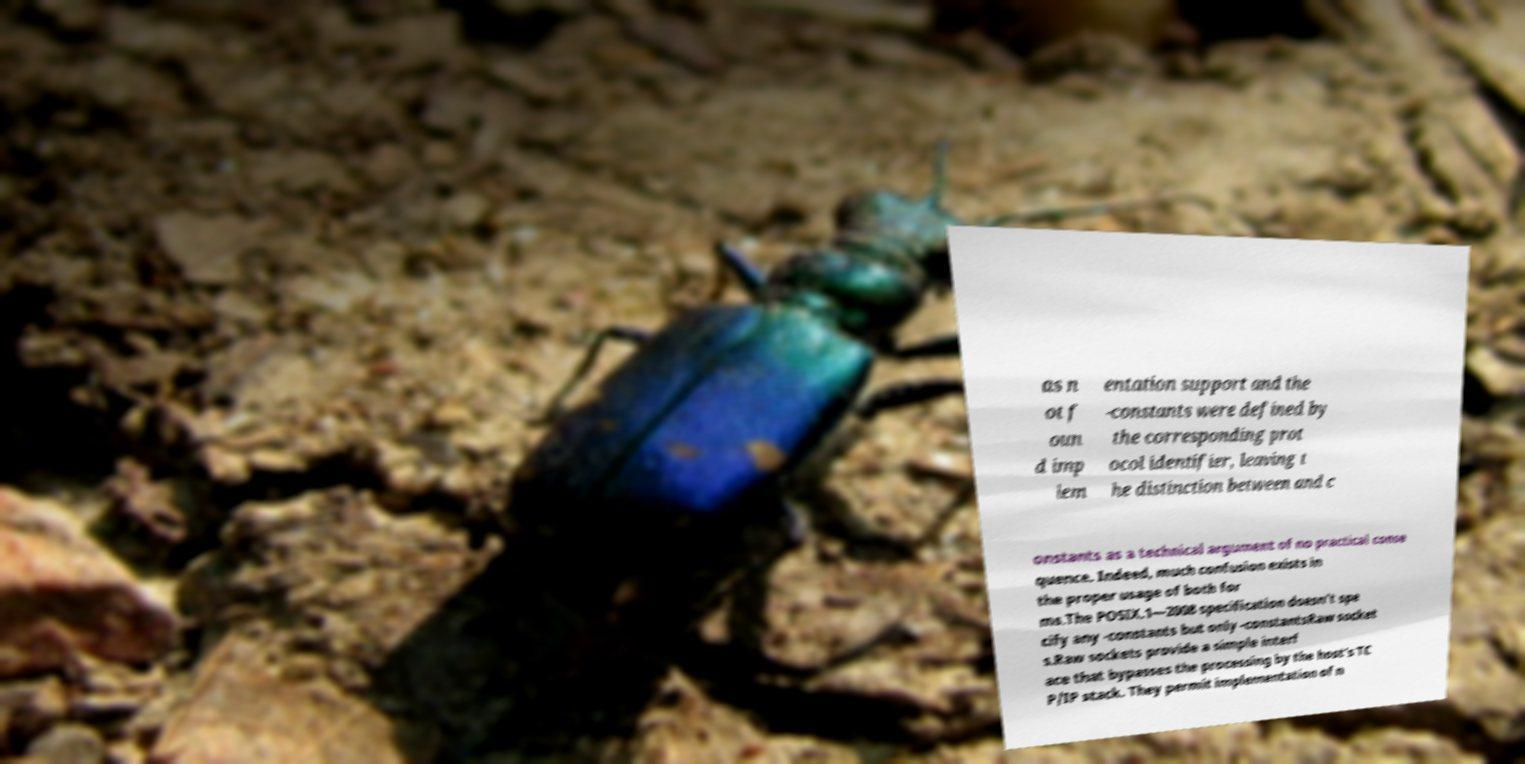There's text embedded in this image that I need extracted. Can you transcribe it verbatim? as n ot f oun d imp lem entation support and the -constants were defined by the corresponding prot ocol identifier, leaving t he distinction between and c onstants as a technical argument of no practical conse quence. Indeed, much confusion exists in the proper usage of both for ms.The POSIX.1—2008 specification doesn't spe cify any -constants but only -constantsRaw socket s.Raw sockets provide a simple interf ace that bypasses the processing by the host's TC P/IP stack. They permit implementation of n 